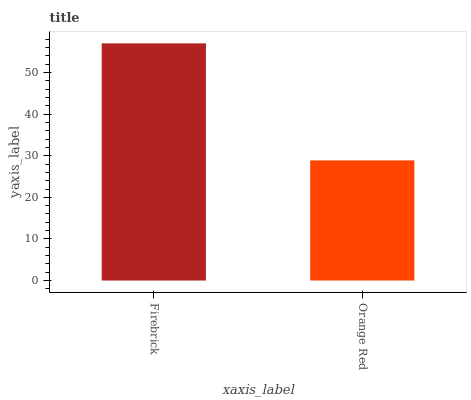Is Orange Red the minimum?
Answer yes or no. Yes. Is Firebrick the maximum?
Answer yes or no. Yes. Is Orange Red the maximum?
Answer yes or no. No. Is Firebrick greater than Orange Red?
Answer yes or no. Yes. Is Orange Red less than Firebrick?
Answer yes or no. Yes. Is Orange Red greater than Firebrick?
Answer yes or no. No. Is Firebrick less than Orange Red?
Answer yes or no. No. Is Firebrick the high median?
Answer yes or no. Yes. Is Orange Red the low median?
Answer yes or no. Yes. Is Orange Red the high median?
Answer yes or no. No. Is Firebrick the low median?
Answer yes or no. No. 